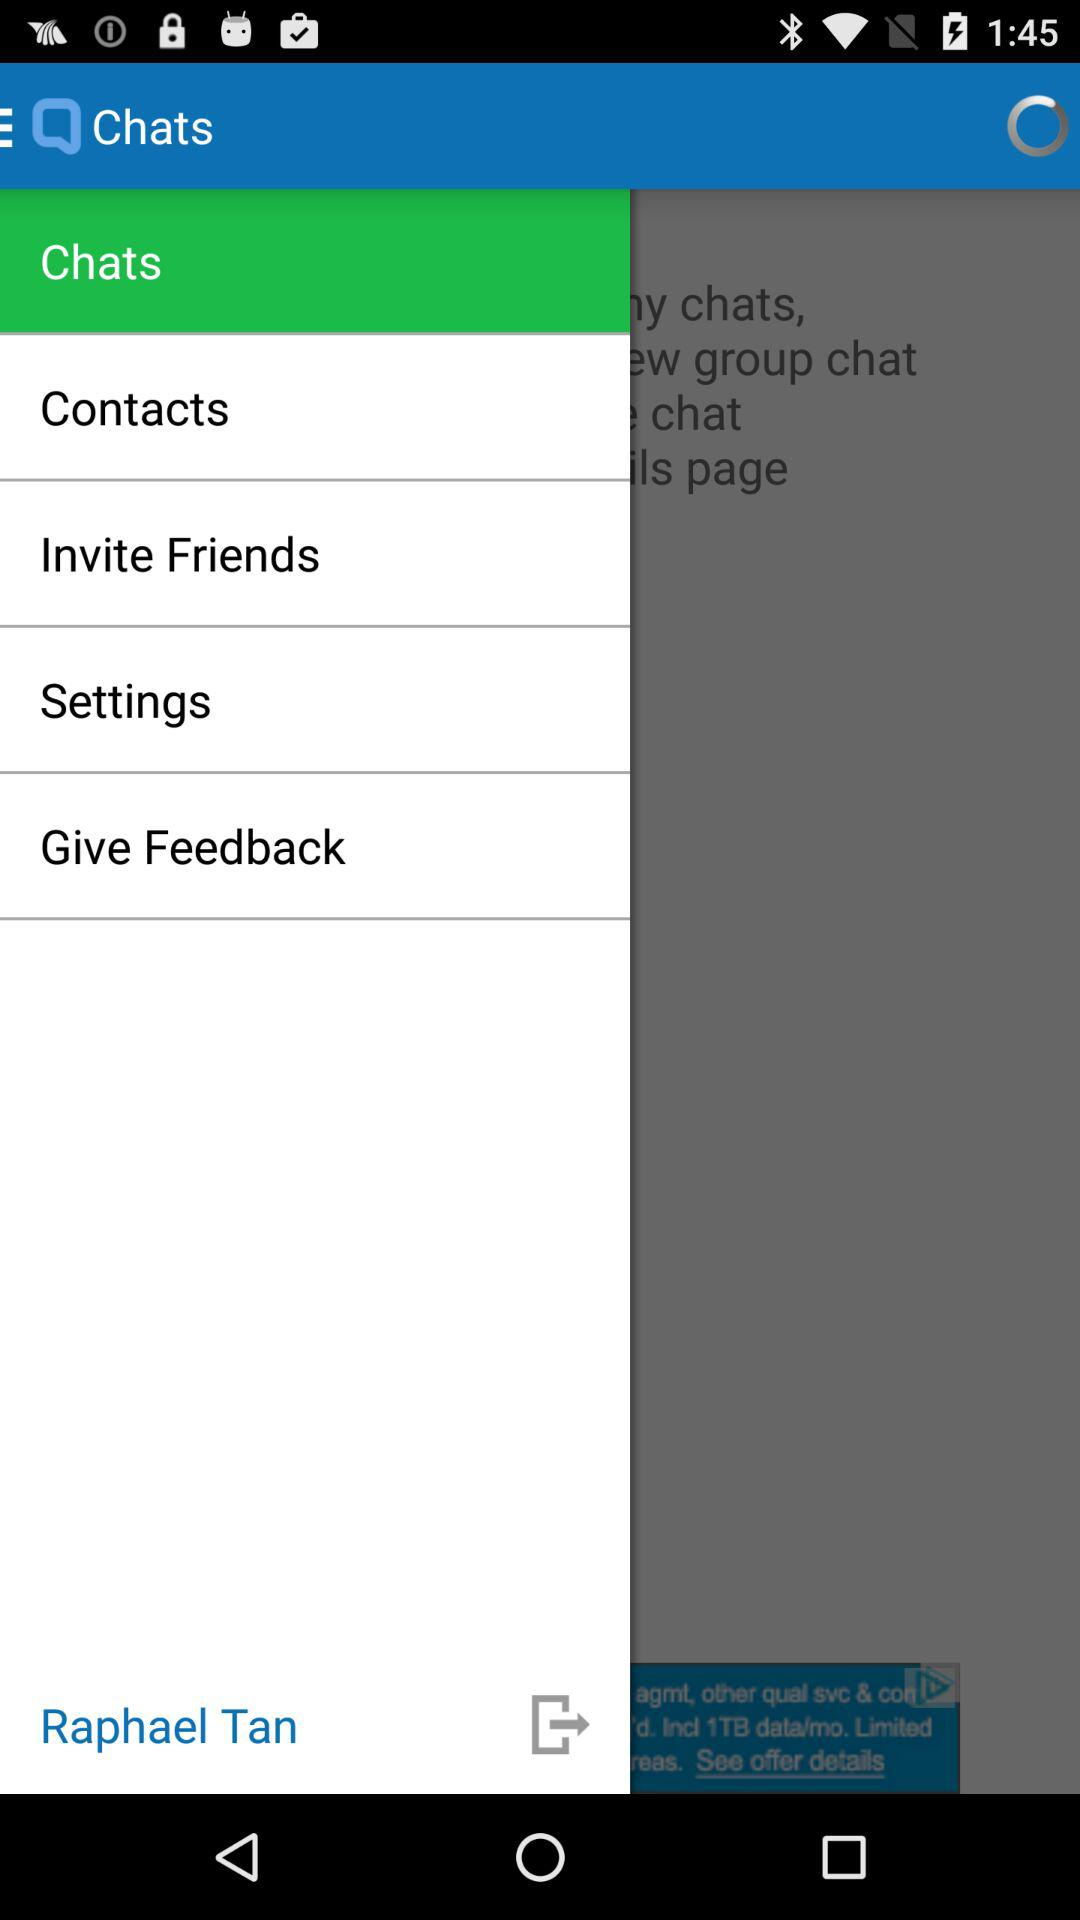What is the user name? The user name is Raphael Tan. 